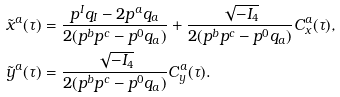Convert formula to latex. <formula><loc_0><loc_0><loc_500><loc_500>\tilde { x } ^ { a } ( \tau ) & = \frac { p ^ { I } q _ { I } - 2 p ^ { a } q _ { a } } { 2 ( p ^ { b } p ^ { c } - p ^ { 0 } q _ { a } ) } + \frac { \sqrt { - I _ { 4 } } } { 2 ( p ^ { b } p ^ { c } - p ^ { 0 } q _ { a } ) } C ^ { a } _ { x } ( \tau ) , \\ \tilde { y } ^ { a } ( \tau ) & = \frac { \sqrt { - I _ { 4 } } } { 2 ( p ^ { b } p ^ { c } - p ^ { 0 } q _ { a } ) } C ^ { a } _ { y } ( \tau ) .</formula> 